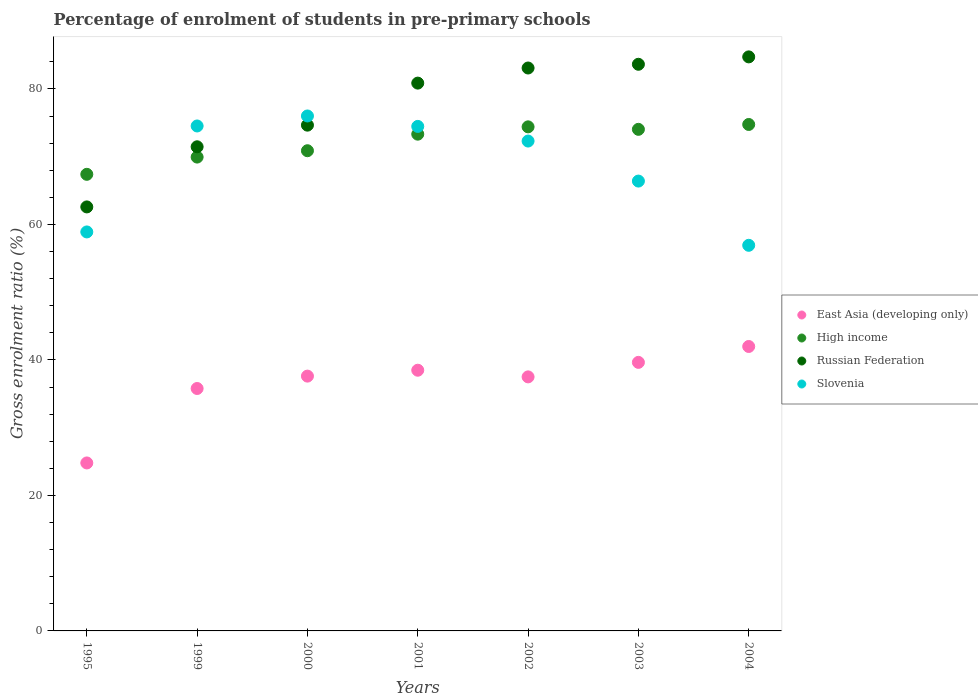Is the number of dotlines equal to the number of legend labels?
Ensure brevity in your answer.  Yes. What is the percentage of students enrolled in pre-primary schools in Russian Federation in 2002?
Your answer should be compact. 83.09. Across all years, what is the maximum percentage of students enrolled in pre-primary schools in Slovenia?
Keep it short and to the point. 76.01. Across all years, what is the minimum percentage of students enrolled in pre-primary schools in East Asia (developing only)?
Make the answer very short. 24.79. What is the total percentage of students enrolled in pre-primary schools in Slovenia in the graph?
Your answer should be very brief. 479.54. What is the difference between the percentage of students enrolled in pre-primary schools in Slovenia in 2000 and that in 2003?
Your answer should be compact. 9.61. What is the difference between the percentage of students enrolled in pre-primary schools in Slovenia in 2003 and the percentage of students enrolled in pre-primary schools in East Asia (developing only) in 1999?
Provide a short and direct response. 30.62. What is the average percentage of students enrolled in pre-primary schools in High income per year?
Make the answer very short. 72.11. In the year 2001, what is the difference between the percentage of students enrolled in pre-primary schools in Russian Federation and percentage of students enrolled in pre-primary schools in East Asia (developing only)?
Your answer should be compact. 42.38. What is the ratio of the percentage of students enrolled in pre-primary schools in East Asia (developing only) in 2000 to that in 2003?
Ensure brevity in your answer.  0.95. What is the difference between the highest and the second highest percentage of students enrolled in pre-primary schools in East Asia (developing only)?
Your answer should be very brief. 2.35. What is the difference between the highest and the lowest percentage of students enrolled in pre-primary schools in East Asia (developing only)?
Keep it short and to the point. 17.19. Is the sum of the percentage of students enrolled in pre-primary schools in East Asia (developing only) in 1999 and 2001 greater than the maximum percentage of students enrolled in pre-primary schools in Slovenia across all years?
Your answer should be very brief. No. Is it the case that in every year, the sum of the percentage of students enrolled in pre-primary schools in High income and percentage of students enrolled in pre-primary schools in East Asia (developing only)  is greater than the percentage of students enrolled in pre-primary schools in Russian Federation?
Your response must be concise. Yes. Is the percentage of students enrolled in pre-primary schools in East Asia (developing only) strictly greater than the percentage of students enrolled in pre-primary schools in Slovenia over the years?
Keep it short and to the point. No. Is the percentage of students enrolled in pre-primary schools in Slovenia strictly less than the percentage of students enrolled in pre-primary schools in Russian Federation over the years?
Offer a very short reply. No. How many years are there in the graph?
Your answer should be compact. 7. What is the difference between two consecutive major ticks on the Y-axis?
Make the answer very short. 20. Are the values on the major ticks of Y-axis written in scientific E-notation?
Give a very brief answer. No. Where does the legend appear in the graph?
Your answer should be very brief. Center right. How many legend labels are there?
Offer a terse response. 4. What is the title of the graph?
Your response must be concise. Percentage of enrolment of students in pre-primary schools. What is the label or title of the X-axis?
Provide a succinct answer. Years. What is the label or title of the Y-axis?
Provide a succinct answer. Gross enrolment ratio (%). What is the Gross enrolment ratio (%) of East Asia (developing only) in 1995?
Give a very brief answer. 24.79. What is the Gross enrolment ratio (%) of High income in 1995?
Your answer should be very brief. 67.4. What is the Gross enrolment ratio (%) in Russian Federation in 1995?
Offer a very short reply. 62.59. What is the Gross enrolment ratio (%) of Slovenia in 1995?
Provide a succinct answer. 58.89. What is the Gross enrolment ratio (%) in East Asia (developing only) in 1999?
Make the answer very short. 35.78. What is the Gross enrolment ratio (%) in High income in 1999?
Provide a short and direct response. 69.94. What is the Gross enrolment ratio (%) of Russian Federation in 1999?
Keep it short and to the point. 71.46. What is the Gross enrolment ratio (%) of Slovenia in 1999?
Keep it short and to the point. 74.54. What is the Gross enrolment ratio (%) of East Asia (developing only) in 2000?
Your answer should be compact. 37.61. What is the Gross enrolment ratio (%) of High income in 2000?
Give a very brief answer. 70.88. What is the Gross enrolment ratio (%) of Russian Federation in 2000?
Your answer should be very brief. 74.66. What is the Gross enrolment ratio (%) in Slovenia in 2000?
Your answer should be very brief. 76.01. What is the Gross enrolment ratio (%) of East Asia (developing only) in 2001?
Offer a terse response. 38.48. What is the Gross enrolment ratio (%) of High income in 2001?
Ensure brevity in your answer.  73.33. What is the Gross enrolment ratio (%) in Russian Federation in 2001?
Make the answer very short. 80.86. What is the Gross enrolment ratio (%) of Slovenia in 2001?
Provide a succinct answer. 74.47. What is the Gross enrolment ratio (%) in East Asia (developing only) in 2002?
Ensure brevity in your answer.  37.5. What is the Gross enrolment ratio (%) in High income in 2002?
Offer a terse response. 74.41. What is the Gross enrolment ratio (%) of Russian Federation in 2002?
Your response must be concise. 83.09. What is the Gross enrolment ratio (%) in Slovenia in 2002?
Keep it short and to the point. 72.31. What is the Gross enrolment ratio (%) in East Asia (developing only) in 2003?
Give a very brief answer. 39.64. What is the Gross enrolment ratio (%) in High income in 2003?
Your answer should be compact. 74.04. What is the Gross enrolment ratio (%) in Russian Federation in 2003?
Your answer should be compact. 83.64. What is the Gross enrolment ratio (%) of Slovenia in 2003?
Your response must be concise. 66.4. What is the Gross enrolment ratio (%) of East Asia (developing only) in 2004?
Give a very brief answer. 41.99. What is the Gross enrolment ratio (%) of High income in 2004?
Offer a terse response. 74.76. What is the Gross enrolment ratio (%) of Russian Federation in 2004?
Provide a succinct answer. 84.73. What is the Gross enrolment ratio (%) in Slovenia in 2004?
Your answer should be very brief. 56.92. Across all years, what is the maximum Gross enrolment ratio (%) of East Asia (developing only)?
Ensure brevity in your answer.  41.99. Across all years, what is the maximum Gross enrolment ratio (%) in High income?
Make the answer very short. 74.76. Across all years, what is the maximum Gross enrolment ratio (%) of Russian Federation?
Keep it short and to the point. 84.73. Across all years, what is the maximum Gross enrolment ratio (%) in Slovenia?
Offer a very short reply. 76.01. Across all years, what is the minimum Gross enrolment ratio (%) in East Asia (developing only)?
Your answer should be very brief. 24.79. Across all years, what is the minimum Gross enrolment ratio (%) of High income?
Your answer should be compact. 67.4. Across all years, what is the minimum Gross enrolment ratio (%) in Russian Federation?
Your answer should be compact. 62.59. Across all years, what is the minimum Gross enrolment ratio (%) of Slovenia?
Provide a short and direct response. 56.92. What is the total Gross enrolment ratio (%) of East Asia (developing only) in the graph?
Make the answer very short. 255.8. What is the total Gross enrolment ratio (%) in High income in the graph?
Ensure brevity in your answer.  504.76. What is the total Gross enrolment ratio (%) in Russian Federation in the graph?
Give a very brief answer. 541.04. What is the total Gross enrolment ratio (%) in Slovenia in the graph?
Make the answer very short. 479.54. What is the difference between the Gross enrolment ratio (%) of East Asia (developing only) in 1995 and that in 1999?
Your response must be concise. -10.99. What is the difference between the Gross enrolment ratio (%) in High income in 1995 and that in 1999?
Provide a succinct answer. -2.54. What is the difference between the Gross enrolment ratio (%) of Russian Federation in 1995 and that in 1999?
Make the answer very short. -8.88. What is the difference between the Gross enrolment ratio (%) of Slovenia in 1995 and that in 1999?
Your answer should be very brief. -15.64. What is the difference between the Gross enrolment ratio (%) in East Asia (developing only) in 1995 and that in 2000?
Provide a succinct answer. -12.82. What is the difference between the Gross enrolment ratio (%) in High income in 1995 and that in 2000?
Your answer should be very brief. -3.48. What is the difference between the Gross enrolment ratio (%) of Russian Federation in 1995 and that in 2000?
Make the answer very short. -12.07. What is the difference between the Gross enrolment ratio (%) of Slovenia in 1995 and that in 2000?
Offer a terse response. -17.12. What is the difference between the Gross enrolment ratio (%) in East Asia (developing only) in 1995 and that in 2001?
Provide a short and direct response. -13.69. What is the difference between the Gross enrolment ratio (%) of High income in 1995 and that in 2001?
Provide a succinct answer. -5.93. What is the difference between the Gross enrolment ratio (%) of Russian Federation in 1995 and that in 2001?
Provide a short and direct response. -18.28. What is the difference between the Gross enrolment ratio (%) in Slovenia in 1995 and that in 2001?
Your answer should be compact. -15.58. What is the difference between the Gross enrolment ratio (%) in East Asia (developing only) in 1995 and that in 2002?
Offer a very short reply. -12.71. What is the difference between the Gross enrolment ratio (%) of High income in 1995 and that in 2002?
Provide a succinct answer. -7.01. What is the difference between the Gross enrolment ratio (%) of Russian Federation in 1995 and that in 2002?
Offer a terse response. -20.51. What is the difference between the Gross enrolment ratio (%) of Slovenia in 1995 and that in 2002?
Provide a short and direct response. -13.42. What is the difference between the Gross enrolment ratio (%) in East Asia (developing only) in 1995 and that in 2003?
Provide a short and direct response. -14.85. What is the difference between the Gross enrolment ratio (%) in High income in 1995 and that in 2003?
Provide a short and direct response. -6.64. What is the difference between the Gross enrolment ratio (%) of Russian Federation in 1995 and that in 2003?
Your answer should be compact. -21.05. What is the difference between the Gross enrolment ratio (%) in Slovenia in 1995 and that in 2003?
Your response must be concise. -7.51. What is the difference between the Gross enrolment ratio (%) of East Asia (developing only) in 1995 and that in 2004?
Provide a succinct answer. -17.19. What is the difference between the Gross enrolment ratio (%) of High income in 1995 and that in 2004?
Provide a succinct answer. -7.36. What is the difference between the Gross enrolment ratio (%) of Russian Federation in 1995 and that in 2004?
Keep it short and to the point. -22.15. What is the difference between the Gross enrolment ratio (%) of Slovenia in 1995 and that in 2004?
Keep it short and to the point. 1.97. What is the difference between the Gross enrolment ratio (%) in East Asia (developing only) in 1999 and that in 2000?
Make the answer very short. -1.83. What is the difference between the Gross enrolment ratio (%) in High income in 1999 and that in 2000?
Provide a short and direct response. -0.94. What is the difference between the Gross enrolment ratio (%) in Russian Federation in 1999 and that in 2000?
Your response must be concise. -3.19. What is the difference between the Gross enrolment ratio (%) of Slovenia in 1999 and that in 2000?
Make the answer very short. -1.48. What is the difference between the Gross enrolment ratio (%) of East Asia (developing only) in 1999 and that in 2001?
Offer a very short reply. -2.7. What is the difference between the Gross enrolment ratio (%) in High income in 1999 and that in 2001?
Offer a terse response. -3.38. What is the difference between the Gross enrolment ratio (%) of Russian Federation in 1999 and that in 2001?
Your answer should be compact. -9.4. What is the difference between the Gross enrolment ratio (%) of Slovenia in 1999 and that in 2001?
Make the answer very short. 0.06. What is the difference between the Gross enrolment ratio (%) in East Asia (developing only) in 1999 and that in 2002?
Your answer should be compact. -1.72. What is the difference between the Gross enrolment ratio (%) in High income in 1999 and that in 2002?
Provide a succinct answer. -4.46. What is the difference between the Gross enrolment ratio (%) of Russian Federation in 1999 and that in 2002?
Offer a very short reply. -11.63. What is the difference between the Gross enrolment ratio (%) of Slovenia in 1999 and that in 2002?
Your answer should be compact. 2.23. What is the difference between the Gross enrolment ratio (%) of East Asia (developing only) in 1999 and that in 2003?
Ensure brevity in your answer.  -3.86. What is the difference between the Gross enrolment ratio (%) of High income in 1999 and that in 2003?
Make the answer very short. -4.09. What is the difference between the Gross enrolment ratio (%) in Russian Federation in 1999 and that in 2003?
Make the answer very short. -12.18. What is the difference between the Gross enrolment ratio (%) in Slovenia in 1999 and that in 2003?
Make the answer very short. 8.13. What is the difference between the Gross enrolment ratio (%) of East Asia (developing only) in 1999 and that in 2004?
Your response must be concise. -6.2. What is the difference between the Gross enrolment ratio (%) of High income in 1999 and that in 2004?
Your answer should be very brief. -4.81. What is the difference between the Gross enrolment ratio (%) of Russian Federation in 1999 and that in 2004?
Ensure brevity in your answer.  -13.27. What is the difference between the Gross enrolment ratio (%) in Slovenia in 1999 and that in 2004?
Your response must be concise. 17.62. What is the difference between the Gross enrolment ratio (%) of East Asia (developing only) in 2000 and that in 2001?
Your answer should be compact. -0.87. What is the difference between the Gross enrolment ratio (%) in High income in 2000 and that in 2001?
Keep it short and to the point. -2.44. What is the difference between the Gross enrolment ratio (%) in Russian Federation in 2000 and that in 2001?
Your answer should be very brief. -6.21. What is the difference between the Gross enrolment ratio (%) of Slovenia in 2000 and that in 2001?
Offer a terse response. 1.54. What is the difference between the Gross enrolment ratio (%) in East Asia (developing only) in 2000 and that in 2002?
Give a very brief answer. 0.11. What is the difference between the Gross enrolment ratio (%) in High income in 2000 and that in 2002?
Your answer should be compact. -3.52. What is the difference between the Gross enrolment ratio (%) of Russian Federation in 2000 and that in 2002?
Provide a short and direct response. -8.44. What is the difference between the Gross enrolment ratio (%) of Slovenia in 2000 and that in 2002?
Give a very brief answer. 3.7. What is the difference between the Gross enrolment ratio (%) of East Asia (developing only) in 2000 and that in 2003?
Give a very brief answer. -2.03. What is the difference between the Gross enrolment ratio (%) in High income in 2000 and that in 2003?
Ensure brevity in your answer.  -3.16. What is the difference between the Gross enrolment ratio (%) in Russian Federation in 2000 and that in 2003?
Your answer should be very brief. -8.99. What is the difference between the Gross enrolment ratio (%) in Slovenia in 2000 and that in 2003?
Ensure brevity in your answer.  9.61. What is the difference between the Gross enrolment ratio (%) of East Asia (developing only) in 2000 and that in 2004?
Your answer should be very brief. -4.37. What is the difference between the Gross enrolment ratio (%) in High income in 2000 and that in 2004?
Your answer should be very brief. -3.87. What is the difference between the Gross enrolment ratio (%) of Russian Federation in 2000 and that in 2004?
Provide a short and direct response. -10.08. What is the difference between the Gross enrolment ratio (%) of Slovenia in 2000 and that in 2004?
Offer a terse response. 19.09. What is the difference between the Gross enrolment ratio (%) in East Asia (developing only) in 2001 and that in 2002?
Your answer should be compact. 0.98. What is the difference between the Gross enrolment ratio (%) of High income in 2001 and that in 2002?
Your response must be concise. -1.08. What is the difference between the Gross enrolment ratio (%) of Russian Federation in 2001 and that in 2002?
Make the answer very short. -2.23. What is the difference between the Gross enrolment ratio (%) of Slovenia in 2001 and that in 2002?
Your answer should be compact. 2.16. What is the difference between the Gross enrolment ratio (%) in East Asia (developing only) in 2001 and that in 2003?
Offer a terse response. -1.16. What is the difference between the Gross enrolment ratio (%) of High income in 2001 and that in 2003?
Keep it short and to the point. -0.71. What is the difference between the Gross enrolment ratio (%) in Russian Federation in 2001 and that in 2003?
Provide a succinct answer. -2.78. What is the difference between the Gross enrolment ratio (%) in Slovenia in 2001 and that in 2003?
Provide a short and direct response. 8.07. What is the difference between the Gross enrolment ratio (%) of East Asia (developing only) in 2001 and that in 2004?
Your answer should be very brief. -3.5. What is the difference between the Gross enrolment ratio (%) in High income in 2001 and that in 2004?
Provide a succinct answer. -1.43. What is the difference between the Gross enrolment ratio (%) in Russian Federation in 2001 and that in 2004?
Keep it short and to the point. -3.87. What is the difference between the Gross enrolment ratio (%) of Slovenia in 2001 and that in 2004?
Your answer should be very brief. 17.55. What is the difference between the Gross enrolment ratio (%) of East Asia (developing only) in 2002 and that in 2003?
Keep it short and to the point. -2.14. What is the difference between the Gross enrolment ratio (%) in High income in 2002 and that in 2003?
Your answer should be compact. 0.37. What is the difference between the Gross enrolment ratio (%) of Russian Federation in 2002 and that in 2003?
Make the answer very short. -0.55. What is the difference between the Gross enrolment ratio (%) of Slovenia in 2002 and that in 2003?
Give a very brief answer. 5.91. What is the difference between the Gross enrolment ratio (%) in East Asia (developing only) in 2002 and that in 2004?
Keep it short and to the point. -4.49. What is the difference between the Gross enrolment ratio (%) of High income in 2002 and that in 2004?
Keep it short and to the point. -0.35. What is the difference between the Gross enrolment ratio (%) in Russian Federation in 2002 and that in 2004?
Ensure brevity in your answer.  -1.64. What is the difference between the Gross enrolment ratio (%) of Slovenia in 2002 and that in 2004?
Your answer should be very brief. 15.39. What is the difference between the Gross enrolment ratio (%) in East Asia (developing only) in 2003 and that in 2004?
Provide a short and direct response. -2.35. What is the difference between the Gross enrolment ratio (%) of High income in 2003 and that in 2004?
Give a very brief answer. -0.72. What is the difference between the Gross enrolment ratio (%) of Russian Federation in 2003 and that in 2004?
Make the answer very short. -1.09. What is the difference between the Gross enrolment ratio (%) of Slovenia in 2003 and that in 2004?
Offer a terse response. 9.48. What is the difference between the Gross enrolment ratio (%) of East Asia (developing only) in 1995 and the Gross enrolment ratio (%) of High income in 1999?
Offer a terse response. -45.15. What is the difference between the Gross enrolment ratio (%) in East Asia (developing only) in 1995 and the Gross enrolment ratio (%) in Russian Federation in 1999?
Provide a succinct answer. -46.67. What is the difference between the Gross enrolment ratio (%) of East Asia (developing only) in 1995 and the Gross enrolment ratio (%) of Slovenia in 1999?
Ensure brevity in your answer.  -49.74. What is the difference between the Gross enrolment ratio (%) of High income in 1995 and the Gross enrolment ratio (%) of Russian Federation in 1999?
Your answer should be compact. -4.06. What is the difference between the Gross enrolment ratio (%) of High income in 1995 and the Gross enrolment ratio (%) of Slovenia in 1999?
Offer a very short reply. -7.14. What is the difference between the Gross enrolment ratio (%) of Russian Federation in 1995 and the Gross enrolment ratio (%) of Slovenia in 1999?
Offer a very short reply. -11.95. What is the difference between the Gross enrolment ratio (%) in East Asia (developing only) in 1995 and the Gross enrolment ratio (%) in High income in 2000?
Your answer should be very brief. -46.09. What is the difference between the Gross enrolment ratio (%) of East Asia (developing only) in 1995 and the Gross enrolment ratio (%) of Russian Federation in 2000?
Keep it short and to the point. -49.86. What is the difference between the Gross enrolment ratio (%) in East Asia (developing only) in 1995 and the Gross enrolment ratio (%) in Slovenia in 2000?
Make the answer very short. -51.22. What is the difference between the Gross enrolment ratio (%) in High income in 1995 and the Gross enrolment ratio (%) in Russian Federation in 2000?
Offer a terse response. -7.26. What is the difference between the Gross enrolment ratio (%) of High income in 1995 and the Gross enrolment ratio (%) of Slovenia in 2000?
Give a very brief answer. -8.61. What is the difference between the Gross enrolment ratio (%) of Russian Federation in 1995 and the Gross enrolment ratio (%) of Slovenia in 2000?
Offer a very short reply. -13.42. What is the difference between the Gross enrolment ratio (%) in East Asia (developing only) in 1995 and the Gross enrolment ratio (%) in High income in 2001?
Offer a terse response. -48.53. What is the difference between the Gross enrolment ratio (%) of East Asia (developing only) in 1995 and the Gross enrolment ratio (%) of Russian Federation in 2001?
Provide a succinct answer. -56.07. What is the difference between the Gross enrolment ratio (%) of East Asia (developing only) in 1995 and the Gross enrolment ratio (%) of Slovenia in 2001?
Your answer should be compact. -49.68. What is the difference between the Gross enrolment ratio (%) in High income in 1995 and the Gross enrolment ratio (%) in Russian Federation in 2001?
Your response must be concise. -13.46. What is the difference between the Gross enrolment ratio (%) of High income in 1995 and the Gross enrolment ratio (%) of Slovenia in 2001?
Provide a short and direct response. -7.07. What is the difference between the Gross enrolment ratio (%) in Russian Federation in 1995 and the Gross enrolment ratio (%) in Slovenia in 2001?
Your answer should be compact. -11.88. What is the difference between the Gross enrolment ratio (%) of East Asia (developing only) in 1995 and the Gross enrolment ratio (%) of High income in 2002?
Give a very brief answer. -49.61. What is the difference between the Gross enrolment ratio (%) in East Asia (developing only) in 1995 and the Gross enrolment ratio (%) in Russian Federation in 2002?
Your answer should be very brief. -58.3. What is the difference between the Gross enrolment ratio (%) in East Asia (developing only) in 1995 and the Gross enrolment ratio (%) in Slovenia in 2002?
Keep it short and to the point. -47.52. What is the difference between the Gross enrolment ratio (%) in High income in 1995 and the Gross enrolment ratio (%) in Russian Federation in 2002?
Ensure brevity in your answer.  -15.69. What is the difference between the Gross enrolment ratio (%) of High income in 1995 and the Gross enrolment ratio (%) of Slovenia in 2002?
Offer a very short reply. -4.91. What is the difference between the Gross enrolment ratio (%) of Russian Federation in 1995 and the Gross enrolment ratio (%) of Slovenia in 2002?
Ensure brevity in your answer.  -9.72. What is the difference between the Gross enrolment ratio (%) of East Asia (developing only) in 1995 and the Gross enrolment ratio (%) of High income in 2003?
Keep it short and to the point. -49.24. What is the difference between the Gross enrolment ratio (%) in East Asia (developing only) in 1995 and the Gross enrolment ratio (%) in Russian Federation in 2003?
Keep it short and to the point. -58.85. What is the difference between the Gross enrolment ratio (%) of East Asia (developing only) in 1995 and the Gross enrolment ratio (%) of Slovenia in 2003?
Your response must be concise. -41.61. What is the difference between the Gross enrolment ratio (%) of High income in 1995 and the Gross enrolment ratio (%) of Russian Federation in 2003?
Keep it short and to the point. -16.24. What is the difference between the Gross enrolment ratio (%) in High income in 1995 and the Gross enrolment ratio (%) in Slovenia in 2003?
Offer a very short reply. 1. What is the difference between the Gross enrolment ratio (%) of Russian Federation in 1995 and the Gross enrolment ratio (%) of Slovenia in 2003?
Your response must be concise. -3.81. What is the difference between the Gross enrolment ratio (%) in East Asia (developing only) in 1995 and the Gross enrolment ratio (%) in High income in 2004?
Offer a very short reply. -49.96. What is the difference between the Gross enrolment ratio (%) of East Asia (developing only) in 1995 and the Gross enrolment ratio (%) of Russian Federation in 2004?
Your answer should be very brief. -59.94. What is the difference between the Gross enrolment ratio (%) in East Asia (developing only) in 1995 and the Gross enrolment ratio (%) in Slovenia in 2004?
Provide a succinct answer. -32.13. What is the difference between the Gross enrolment ratio (%) of High income in 1995 and the Gross enrolment ratio (%) of Russian Federation in 2004?
Your response must be concise. -17.34. What is the difference between the Gross enrolment ratio (%) of High income in 1995 and the Gross enrolment ratio (%) of Slovenia in 2004?
Provide a short and direct response. 10.48. What is the difference between the Gross enrolment ratio (%) in Russian Federation in 1995 and the Gross enrolment ratio (%) in Slovenia in 2004?
Your response must be concise. 5.67. What is the difference between the Gross enrolment ratio (%) of East Asia (developing only) in 1999 and the Gross enrolment ratio (%) of High income in 2000?
Keep it short and to the point. -35.1. What is the difference between the Gross enrolment ratio (%) in East Asia (developing only) in 1999 and the Gross enrolment ratio (%) in Russian Federation in 2000?
Offer a very short reply. -38.87. What is the difference between the Gross enrolment ratio (%) in East Asia (developing only) in 1999 and the Gross enrolment ratio (%) in Slovenia in 2000?
Your answer should be very brief. -40.23. What is the difference between the Gross enrolment ratio (%) in High income in 1999 and the Gross enrolment ratio (%) in Russian Federation in 2000?
Make the answer very short. -4.71. What is the difference between the Gross enrolment ratio (%) in High income in 1999 and the Gross enrolment ratio (%) in Slovenia in 2000?
Ensure brevity in your answer.  -6.07. What is the difference between the Gross enrolment ratio (%) of Russian Federation in 1999 and the Gross enrolment ratio (%) of Slovenia in 2000?
Offer a very short reply. -4.55. What is the difference between the Gross enrolment ratio (%) of East Asia (developing only) in 1999 and the Gross enrolment ratio (%) of High income in 2001?
Keep it short and to the point. -37.54. What is the difference between the Gross enrolment ratio (%) in East Asia (developing only) in 1999 and the Gross enrolment ratio (%) in Russian Federation in 2001?
Offer a very short reply. -45.08. What is the difference between the Gross enrolment ratio (%) of East Asia (developing only) in 1999 and the Gross enrolment ratio (%) of Slovenia in 2001?
Your answer should be very brief. -38.69. What is the difference between the Gross enrolment ratio (%) in High income in 1999 and the Gross enrolment ratio (%) in Russian Federation in 2001?
Ensure brevity in your answer.  -10.92. What is the difference between the Gross enrolment ratio (%) of High income in 1999 and the Gross enrolment ratio (%) of Slovenia in 2001?
Your answer should be very brief. -4.53. What is the difference between the Gross enrolment ratio (%) of Russian Federation in 1999 and the Gross enrolment ratio (%) of Slovenia in 2001?
Give a very brief answer. -3.01. What is the difference between the Gross enrolment ratio (%) in East Asia (developing only) in 1999 and the Gross enrolment ratio (%) in High income in 2002?
Keep it short and to the point. -38.62. What is the difference between the Gross enrolment ratio (%) of East Asia (developing only) in 1999 and the Gross enrolment ratio (%) of Russian Federation in 2002?
Keep it short and to the point. -47.31. What is the difference between the Gross enrolment ratio (%) of East Asia (developing only) in 1999 and the Gross enrolment ratio (%) of Slovenia in 2002?
Your response must be concise. -36.53. What is the difference between the Gross enrolment ratio (%) in High income in 1999 and the Gross enrolment ratio (%) in Russian Federation in 2002?
Give a very brief answer. -13.15. What is the difference between the Gross enrolment ratio (%) of High income in 1999 and the Gross enrolment ratio (%) of Slovenia in 2002?
Keep it short and to the point. -2.37. What is the difference between the Gross enrolment ratio (%) of Russian Federation in 1999 and the Gross enrolment ratio (%) of Slovenia in 2002?
Your answer should be compact. -0.85. What is the difference between the Gross enrolment ratio (%) of East Asia (developing only) in 1999 and the Gross enrolment ratio (%) of High income in 2003?
Keep it short and to the point. -38.25. What is the difference between the Gross enrolment ratio (%) in East Asia (developing only) in 1999 and the Gross enrolment ratio (%) in Russian Federation in 2003?
Your response must be concise. -47.86. What is the difference between the Gross enrolment ratio (%) in East Asia (developing only) in 1999 and the Gross enrolment ratio (%) in Slovenia in 2003?
Provide a succinct answer. -30.62. What is the difference between the Gross enrolment ratio (%) in High income in 1999 and the Gross enrolment ratio (%) in Russian Federation in 2003?
Provide a succinct answer. -13.7. What is the difference between the Gross enrolment ratio (%) of High income in 1999 and the Gross enrolment ratio (%) of Slovenia in 2003?
Keep it short and to the point. 3.54. What is the difference between the Gross enrolment ratio (%) of Russian Federation in 1999 and the Gross enrolment ratio (%) of Slovenia in 2003?
Your answer should be very brief. 5.06. What is the difference between the Gross enrolment ratio (%) of East Asia (developing only) in 1999 and the Gross enrolment ratio (%) of High income in 2004?
Provide a succinct answer. -38.97. What is the difference between the Gross enrolment ratio (%) of East Asia (developing only) in 1999 and the Gross enrolment ratio (%) of Russian Federation in 2004?
Provide a short and direct response. -48.95. What is the difference between the Gross enrolment ratio (%) of East Asia (developing only) in 1999 and the Gross enrolment ratio (%) of Slovenia in 2004?
Make the answer very short. -21.14. What is the difference between the Gross enrolment ratio (%) of High income in 1999 and the Gross enrolment ratio (%) of Russian Federation in 2004?
Give a very brief answer. -14.79. What is the difference between the Gross enrolment ratio (%) in High income in 1999 and the Gross enrolment ratio (%) in Slovenia in 2004?
Give a very brief answer. 13.02. What is the difference between the Gross enrolment ratio (%) in Russian Federation in 1999 and the Gross enrolment ratio (%) in Slovenia in 2004?
Make the answer very short. 14.54. What is the difference between the Gross enrolment ratio (%) of East Asia (developing only) in 2000 and the Gross enrolment ratio (%) of High income in 2001?
Provide a short and direct response. -35.72. What is the difference between the Gross enrolment ratio (%) of East Asia (developing only) in 2000 and the Gross enrolment ratio (%) of Russian Federation in 2001?
Provide a short and direct response. -43.25. What is the difference between the Gross enrolment ratio (%) of East Asia (developing only) in 2000 and the Gross enrolment ratio (%) of Slovenia in 2001?
Your response must be concise. -36.86. What is the difference between the Gross enrolment ratio (%) of High income in 2000 and the Gross enrolment ratio (%) of Russian Federation in 2001?
Offer a very short reply. -9.98. What is the difference between the Gross enrolment ratio (%) of High income in 2000 and the Gross enrolment ratio (%) of Slovenia in 2001?
Your answer should be very brief. -3.59. What is the difference between the Gross enrolment ratio (%) in Russian Federation in 2000 and the Gross enrolment ratio (%) in Slovenia in 2001?
Provide a short and direct response. 0.19. What is the difference between the Gross enrolment ratio (%) in East Asia (developing only) in 2000 and the Gross enrolment ratio (%) in High income in 2002?
Offer a very short reply. -36.79. What is the difference between the Gross enrolment ratio (%) in East Asia (developing only) in 2000 and the Gross enrolment ratio (%) in Russian Federation in 2002?
Offer a very short reply. -45.48. What is the difference between the Gross enrolment ratio (%) of East Asia (developing only) in 2000 and the Gross enrolment ratio (%) of Slovenia in 2002?
Your response must be concise. -34.7. What is the difference between the Gross enrolment ratio (%) of High income in 2000 and the Gross enrolment ratio (%) of Russian Federation in 2002?
Make the answer very short. -12.21. What is the difference between the Gross enrolment ratio (%) of High income in 2000 and the Gross enrolment ratio (%) of Slovenia in 2002?
Your answer should be very brief. -1.43. What is the difference between the Gross enrolment ratio (%) of Russian Federation in 2000 and the Gross enrolment ratio (%) of Slovenia in 2002?
Your answer should be compact. 2.35. What is the difference between the Gross enrolment ratio (%) in East Asia (developing only) in 2000 and the Gross enrolment ratio (%) in High income in 2003?
Keep it short and to the point. -36.43. What is the difference between the Gross enrolment ratio (%) of East Asia (developing only) in 2000 and the Gross enrolment ratio (%) of Russian Federation in 2003?
Give a very brief answer. -46.03. What is the difference between the Gross enrolment ratio (%) in East Asia (developing only) in 2000 and the Gross enrolment ratio (%) in Slovenia in 2003?
Your response must be concise. -28.79. What is the difference between the Gross enrolment ratio (%) in High income in 2000 and the Gross enrolment ratio (%) in Russian Federation in 2003?
Offer a very short reply. -12.76. What is the difference between the Gross enrolment ratio (%) of High income in 2000 and the Gross enrolment ratio (%) of Slovenia in 2003?
Ensure brevity in your answer.  4.48. What is the difference between the Gross enrolment ratio (%) in Russian Federation in 2000 and the Gross enrolment ratio (%) in Slovenia in 2003?
Offer a terse response. 8.26. What is the difference between the Gross enrolment ratio (%) in East Asia (developing only) in 2000 and the Gross enrolment ratio (%) in High income in 2004?
Give a very brief answer. -37.15. What is the difference between the Gross enrolment ratio (%) of East Asia (developing only) in 2000 and the Gross enrolment ratio (%) of Russian Federation in 2004?
Your answer should be very brief. -47.12. What is the difference between the Gross enrolment ratio (%) in East Asia (developing only) in 2000 and the Gross enrolment ratio (%) in Slovenia in 2004?
Ensure brevity in your answer.  -19.31. What is the difference between the Gross enrolment ratio (%) of High income in 2000 and the Gross enrolment ratio (%) of Russian Federation in 2004?
Ensure brevity in your answer.  -13.85. What is the difference between the Gross enrolment ratio (%) in High income in 2000 and the Gross enrolment ratio (%) in Slovenia in 2004?
Your answer should be very brief. 13.96. What is the difference between the Gross enrolment ratio (%) of Russian Federation in 2000 and the Gross enrolment ratio (%) of Slovenia in 2004?
Your answer should be compact. 17.74. What is the difference between the Gross enrolment ratio (%) of East Asia (developing only) in 2001 and the Gross enrolment ratio (%) of High income in 2002?
Keep it short and to the point. -35.92. What is the difference between the Gross enrolment ratio (%) in East Asia (developing only) in 2001 and the Gross enrolment ratio (%) in Russian Federation in 2002?
Give a very brief answer. -44.61. What is the difference between the Gross enrolment ratio (%) of East Asia (developing only) in 2001 and the Gross enrolment ratio (%) of Slovenia in 2002?
Your response must be concise. -33.83. What is the difference between the Gross enrolment ratio (%) in High income in 2001 and the Gross enrolment ratio (%) in Russian Federation in 2002?
Ensure brevity in your answer.  -9.77. What is the difference between the Gross enrolment ratio (%) in High income in 2001 and the Gross enrolment ratio (%) in Slovenia in 2002?
Make the answer very short. 1.02. What is the difference between the Gross enrolment ratio (%) in Russian Federation in 2001 and the Gross enrolment ratio (%) in Slovenia in 2002?
Offer a terse response. 8.55. What is the difference between the Gross enrolment ratio (%) of East Asia (developing only) in 2001 and the Gross enrolment ratio (%) of High income in 2003?
Offer a terse response. -35.56. What is the difference between the Gross enrolment ratio (%) of East Asia (developing only) in 2001 and the Gross enrolment ratio (%) of Russian Federation in 2003?
Make the answer very short. -45.16. What is the difference between the Gross enrolment ratio (%) in East Asia (developing only) in 2001 and the Gross enrolment ratio (%) in Slovenia in 2003?
Offer a very short reply. -27.92. What is the difference between the Gross enrolment ratio (%) of High income in 2001 and the Gross enrolment ratio (%) of Russian Federation in 2003?
Your response must be concise. -10.32. What is the difference between the Gross enrolment ratio (%) in High income in 2001 and the Gross enrolment ratio (%) in Slovenia in 2003?
Offer a very short reply. 6.93. What is the difference between the Gross enrolment ratio (%) of Russian Federation in 2001 and the Gross enrolment ratio (%) of Slovenia in 2003?
Keep it short and to the point. 14.46. What is the difference between the Gross enrolment ratio (%) in East Asia (developing only) in 2001 and the Gross enrolment ratio (%) in High income in 2004?
Keep it short and to the point. -36.28. What is the difference between the Gross enrolment ratio (%) in East Asia (developing only) in 2001 and the Gross enrolment ratio (%) in Russian Federation in 2004?
Provide a short and direct response. -46.25. What is the difference between the Gross enrolment ratio (%) in East Asia (developing only) in 2001 and the Gross enrolment ratio (%) in Slovenia in 2004?
Your response must be concise. -18.44. What is the difference between the Gross enrolment ratio (%) of High income in 2001 and the Gross enrolment ratio (%) of Russian Federation in 2004?
Make the answer very short. -11.41. What is the difference between the Gross enrolment ratio (%) in High income in 2001 and the Gross enrolment ratio (%) in Slovenia in 2004?
Your answer should be compact. 16.41. What is the difference between the Gross enrolment ratio (%) of Russian Federation in 2001 and the Gross enrolment ratio (%) of Slovenia in 2004?
Make the answer very short. 23.94. What is the difference between the Gross enrolment ratio (%) in East Asia (developing only) in 2002 and the Gross enrolment ratio (%) in High income in 2003?
Provide a short and direct response. -36.54. What is the difference between the Gross enrolment ratio (%) in East Asia (developing only) in 2002 and the Gross enrolment ratio (%) in Russian Federation in 2003?
Provide a succinct answer. -46.14. What is the difference between the Gross enrolment ratio (%) of East Asia (developing only) in 2002 and the Gross enrolment ratio (%) of Slovenia in 2003?
Your answer should be very brief. -28.9. What is the difference between the Gross enrolment ratio (%) of High income in 2002 and the Gross enrolment ratio (%) of Russian Federation in 2003?
Offer a very short reply. -9.24. What is the difference between the Gross enrolment ratio (%) in High income in 2002 and the Gross enrolment ratio (%) in Slovenia in 2003?
Provide a succinct answer. 8. What is the difference between the Gross enrolment ratio (%) of Russian Federation in 2002 and the Gross enrolment ratio (%) of Slovenia in 2003?
Keep it short and to the point. 16.69. What is the difference between the Gross enrolment ratio (%) in East Asia (developing only) in 2002 and the Gross enrolment ratio (%) in High income in 2004?
Provide a short and direct response. -37.26. What is the difference between the Gross enrolment ratio (%) of East Asia (developing only) in 2002 and the Gross enrolment ratio (%) of Russian Federation in 2004?
Make the answer very short. -47.24. What is the difference between the Gross enrolment ratio (%) of East Asia (developing only) in 2002 and the Gross enrolment ratio (%) of Slovenia in 2004?
Your response must be concise. -19.42. What is the difference between the Gross enrolment ratio (%) of High income in 2002 and the Gross enrolment ratio (%) of Russian Federation in 2004?
Your answer should be compact. -10.33. What is the difference between the Gross enrolment ratio (%) in High income in 2002 and the Gross enrolment ratio (%) in Slovenia in 2004?
Offer a terse response. 17.49. What is the difference between the Gross enrolment ratio (%) in Russian Federation in 2002 and the Gross enrolment ratio (%) in Slovenia in 2004?
Provide a succinct answer. 26.17. What is the difference between the Gross enrolment ratio (%) of East Asia (developing only) in 2003 and the Gross enrolment ratio (%) of High income in 2004?
Your answer should be compact. -35.12. What is the difference between the Gross enrolment ratio (%) in East Asia (developing only) in 2003 and the Gross enrolment ratio (%) in Russian Federation in 2004?
Your response must be concise. -45.09. What is the difference between the Gross enrolment ratio (%) of East Asia (developing only) in 2003 and the Gross enrolment ratio (%) of Slovenia in 2004?
Keep it short and to the point. -17.28. What is the difference between the Gross enrolment ratio (%) in High income in 2003 and the Gross enrolment ratio (%) in Russian Federation in 2004?
Your response must be concise. -10.7. What is the difference between the Gross enrolment ratio (%) of High income in 2003 and the Gross enrolment ratio (%) of Slovenia in 2004?
Offer a very short reply. 17.12. What is the difference between the Gross enrolment ratio (%) in Russian Federation in 2003 and the Gross enrolment ratio (%) in Slovenia in 2004?
Your answer should be compact. 26.72. What is the average Gross enrolment ratio (%) of East Asia (developing only) per year?
Offer a very short reply. 36.54. What is the average Gross enrolment ratio (%) of High income per year?
Make the answer very short. 72.11. What is the average Gross enrolment ratio (%) of Russian Federation per year?
Your answer should be compact. 77.29. What is the average Gross enrolment ratio (%) in Slovenia per year?
Make the answer very short. 68.51. In the year 1995, what is the difference between the Gross enrolment ratio (%) in East Asia (developing only) and Gross enrolment ratio (%) in High income?
Offer a terse response. -42.6. In the year 1995, what is the difference between the Gross enrolment ratio (%) of East Asia (developing only) and Gross enrolment ratio (%) of Russian Federation?
Make the answer very short. -37.79. In the year 1995, what is the difference between the Gross enrolment ratio (%) in East Asia (developing only) and Gross enrolment ratio (%) in Slovenia?
Provide a short and direct response. -34.1. In the year 1995, what is the difference between the Gross enrolment ratio (%) in High income and Gross enrolment ratio (%) in Russian Federation?
Your answer should be very brief. 4.81. In the year 1995, what is the difference between the Gross enrolment ratio (%) in High income and Gross enrolment ratio (%) in Slovenia?
Your answer should be compact. 8.51. In the year 1995, what is the difference between the Gross enrolment ratio (%) in Russian Federation and Gross enrolment ratio (%) in Slovenia?
Ensure brevity in your answer.  3.69. In the year 1999, what is the difference between the Gross enrolment ratio (%) in East Asia (developing only) and Gross enrolment ratio (%) in High income?
Your response must be concise. -34.16. In the year 1999, what is the difference between the Gross enrolment ratio (%) of East Asia (developing only) and Gross enrolment ratio (%) of Russian Federation?
Make the answer very short. -35.68. In the year 1999, what is the difference between the Gross enrolment ratio (%) in East Asia (developing only) and Gross enrolment ratio (%) in Slovenia?
Provide a short and direct response. -38.75. In the year 1999, what is the difference between the Gross enrolment ratio (%) in High income and Gross enrolment ratio (%) in Russian Federation?
Offer a very short reply. -1.52. In the year 1999, what is the difference between the Gross enrolment ratio (%) in High income and Gross enrolment ratio (%) in Slovenia?
Give a very brief answer. -4.59. In the year 1999, what is the difference between the Gross enrolment ratio (%) of Russian Federation and Gross enrolment ratio (%) of Slovenia?
Provide a short and direct response. -3.07. In the year 2000, what is the difference between the Gross enrolment ratio (%) in East Asia (developing only) and Gross enrolment ratio (%) in High income?
Your answer should be compact. -33.27. In the year 2000, what is the difference between the Gross enrolment ratio (%) of East Asia (developing only) and Gross enrolment ratio (%) of Russian Federation?
Make the answer very short. -37.04. In the year 2000, what is the difference between the Gross enrolment ratio (%) of East Asia (developing only) and Gross enrolment ratio (%) of Slovenia?
Your answer should be very brief. -38.4. In the year 2000, what is the difference between the Gross enrolment ratio (%) of High income and Gross enrolment ratio (%) of Russian Federation?
Offer a very short reply. -3.77. In the year 2000, what is the difference between the Gross enrolment ratio (%) in High income and Gross enrolment ratio (%) in Slovenia?
Give a very brief answer. -5.13. In the year 2000, what is the difference between the Gross enrolment ratio (%) in Russian Federation and Gross enrolment ratio (%) in Slovenia?
Your response must be concise. -1.36. In the year 2001, what is the difference between the Gross enrolment ratio (%) in East Asia (developing only) and Gross enrolment ratio (%) in High income?
Give a very brief answer. -34.85. In the year 2001, what is the difference between the Gross enrolment ratio (%) of East Asia (developing only) and Gross enrolment ratio (%) of Russian Federation?
Offer a very short reply. -42.38. In the year 2001, what is the difference between the Gross enrolment ratio (%) of East Asia (developing only) and Gross enrolment ratio (%) of Slovenia?
Provide a short and direct response. -35.99. In the year 2001, what is the difference between the Gross enrolment ratio (%) in High income and Gross enrolment ratio (%) in Russian Federation?
Your answer should be very brief. -7.54. In the year 2001, what is the difference between the Gross enrolment ratio (%) of High income and Gross enrolment ratio (%) of Slovenia?
Ensure brevity in your answer.  -1.14. In the year 2001, what is the difference between the Gross enrolment ratio (%) in Russian Federation and Gross enrolment ratio (%) in Slovenia?
Give a very brief answer. 6.39. In the year 2002, what is the difference between the Gross enrolment ratio (%) of East Asia (developing only) and Gross enrolment ratio (%) of High income?
Your answer should be very brief. -36.91. In the year 2002, what is the difference between the Gross enrolment ratio (%) of East Asia (developing only) and Gross enrolment ratio (%) of Russian Federation?
Ensure brevity in your answer.  -45.59. In the year 2002, what is the difference between the Gross enrolment ratio (%) of East Asia (developing only) and Gross enrolment ratio (%) of Slovenia?
Provide a short and direct response. -34.81. In the year 2002, what is the difference between the Gross enrolment ratio (%) of High income and Gross enrolment ratio (%) of Russian Federation?
Offer a very short reply. -8.69. In the year 2002, what is the difference between the Gross enrolment ratio (%) in High income and Gross enrolment ratio (%) in Slovenia?
Make the answer very short. 2.1. In the year 2002, what is the difference between the Gross enrolment ratio (%) of Russian Federation and Gross enrolment ratio (%) of Slovenia?
Make the answer very short. 10.78. In the year 2003, what is the difference between the Gross enrolment ratio (%) in East Asia (developing only) and Gross enrolment ratio (%) in High income?
Make the answer very short. -34.4. In the year 2003, what is the difference between the Gross enrolment ratio (%) in East Asia (developing only) and Gross enrolment ratio (%) in Russian Federation?
Provide a succinct answer. -44. In the year 2003, what is the difference between the Gross enrolment ratio (%) in East Asia (developing only) and Gross enrolment ratio (%) in Slovenia?
Ensure brevity in your answer.  -26.76. In the year 2003, what is the difference between the Gross enrolment ratio (%) in High income and Gross enrolment ratio (%) in Russian Federation?
Give a very brief answer. -9.6. In the year 2003, what is the difference between the Gross enrolment ratio (%) in High income and Gross enrolment ratio (%) in Slovenia?
Your response must be concise. 7.64. In the year 2003, what is the difference between the Gross enrolment ratio (%) of Russian Federation and Gross enrolment ratio (%) of Slovenia?
Offer a terse response. 17.24. In the year 2004, what is the difference between the Gross enrolment ratio (%) in East Asia (developing only) and Gross enrolment ratio (%) in High income?
Make the answer very short. -32.77. In the year 2004, what is the difference between the Gross enrolment ratio (%) of East Asia (developing only) and Gross enrolment ratio (%) of Russian Federation?
Your answer should be compact. -42.75. In the year 2004, what is the difference between the Gross enrolment ratio (%) of East Asia (developing only) and Gross enrolment ratio (%) of Slovenia?
Give a very brief answer. -14.93. In the year 2004, what is the difference between the Gross enrolment ratio (%) of High income and Gross enrolment ratio (%) of Russian Federation?
Your answer should be compact. -9.98. In the year 2004, what is the difference between the Gross enrolment ratio (%) of High income and Gross enrolment ratio (%) of Slovenia?
Make the answer very short. 17.84. In the year 2004, what is the difference between the Gross enrolment ratio (%) in Russian Federation and Gross enrolment ratio (%) in Slovenia?
Provide a succinct answer. 27.81. What is the ratio of the Gross enrolment ratio (%) in East Asia (developing only) in 1995 to that in 1999?
Make the answer very short. 0.69. What is the ratio of the Gross enrolment ratio (%) in High income in 1995 to that in 1999?
Ensure brevity in your answer.  0.96. What is the ratio of the Gross enrolment ratio (%) in Russian Federation in 1995 to that in 1999?
Offer a very short reply. 0.88. What is the ratio of the Gross enrolment ratio (%) in Slovenia in 1995 to that in 1999?
Your response must be concise. 0.79. What is the ratio of the Gross enrolment ratio (%) in East Asia (developing only) in 1995 to that in 2000?
Provide a succinct answer. 0.66. What is the ratio of the Gross enrolment ratio (%) of High income in 1995 to that in 2000?
Make the answer very short. 0.95. What is the ratio of the Gross enrolment ratio (%) in Russian Federation in 1995 to that in 2000?
Your answer should be very brief. 0.84. What is the ratio of the Gross enrolment ratio (%) in Slovenia in 1995 to that in 2000?
Offer a very short reply. 0.77. What is the ratio of the Gross enrolment ratio (%) in East Asia (developing only) in 1995 to that in 2001?
Your answer should be compact. 0.64. What is the ratio of the Gross enrolment ratio (%) of High income in 1995 to that in 2001?
Provide a succinct answer. 0.92. What is the ratio of the Gross enrolment ratio (%) in Russian Federation in 1995 to that in 2001?
Keep it short and to the point. 0.77. What is the ratio of the Gross enrolment ratio (%) of Slovenia in 1995 to that in 2001?
Make the answer very short. 0.79. What is the ratio of the Gross enrolment ratio (%) of East Asia (developing only) in 1995 to that in 2002?
Provide a short and direct response. 0.66. What is the ratio of the Gross enrolment ratio (%) in High income in 1995 to that in 2002?
Make the answer very short. 0.91. What is the ratio of the Gross enrolment ratio (%) of Russian Federation in 1995 to that in 2002?
Make the answer very short. 0.75. What is the ratio of the Gross enrolment ratio (%) in Slovenia in 1995 to that in 2002?
Your response must be concise. 0.81. What is the ratio of the Gross enrolment ratio (%) in East Asia (developing only) in 1995 to that in 2003?
Ensure brevity in your answer.  0.63. What is the ratio of the Gross enrolment ratio (%) in High income in 1995 to that in 2003?
Keep it short and to the point. 0.91. What is the ratio of the Gross enrolment ratio (%) in Russian Federation in 1995 to that in 2003?
Provide a succinct answer. 0.75. What is the ratio of the Gross enrolment ratio (%) of Slovenia in 1995 to that in 2003?
Offer a terse response. 0.89. What is the ratio of the Gross enrolment ratio (%) of East Asia (developing only) in 1995 to that in 2004?
Make the answer very short. 0.59. What is the ratio of the Gross enrolment ratio (%) of High income in 1995 to that in 2004?
Provide a short and direct response. 0.9. What is the ratio of the Gross enrolment ratio (%) of Russian Federation in 1995 to that in 2004?
Provide a succinct answer. 0.74. What is the ratio of the Gross enrolment ratio (%) in Slovenia in 1995 to that in 2004?
Keep it short and to the point. 1.03. What is the ratio of the Gross enrolment ratio (%) of East Asia (developing only) in 1999 to that in 2000?
Your answer should be very brief. 0.95. What is the ratio of the Gross enrolment ratio (%) in Russian Federation in 1999 to that in 2000?
Make the answer very short. 0.96. What is the ratio of the Gross enrolment ratio (%) of Slovenia in 1999 to that in 2000?
Offer a very short reply. 0.98. What is the ratio of the Gross enrolment ratio (%) of East Asia (developing only) in 1999 to that in 2001?
Keep it short and to the point. 0.93. What is the ratio of the Gross enrolment ratio (%) of High income in 1999 to that in 2001?
Your answer should be very brief. 0.95. What is the ratio of the Gross enrolment ratio (%) in Russian Federation in 1999 to that in 2001?
Offer a very short reply. 0.88. What is the ratio of the Gross enrolment ratio (%) in East Asia (developing only) in 1999 to that in 2002?
Your response must be concise. 0.95. What is the ratio of the Gross enrolment ratio (%) of High income in 1999 to that in 2002?
Ensure brevity in your answer.  0.94. What is the ratio of the Gross enrolment ratio (%) of Russian Federation in 1999 to that in 2002?
Give a very brief answer. 0.86. What is the ratio of the Gross enrolment ratio (%) in Slovenia in 1999 to that in 2002?
Your answer should be very brief. 1.03. What is the ratio of the Gross enrolment ratio (%) of East Asia (developing only) in 1999 to that in 2003?
Offer a very short reply. 0.9. What is the ratio of the Gross enrolment ratio (%) in High income in 1999 to that in 2003?
Your answer should be very brief. 0.94. What is the ratio of the Gross enrolment ratio (%) of Russian Federation in 1999 to that in 2003?
Provide a short and direct response. 0.85. What is the ratio of the Gross enrolment ratio (%) of Slovenia in 1999 to that in 2003?
Your response must be concise. 1.12. What is the ratio of the Gross enrolment ratio (%) in East Asia (developing only) in 1999 to that in 2004?
Offer a terse response. 0.85. What is the ratio of the Gross enrolment ratio (%) in High income in 1999 to that in 2004?
Provide a succinct answer. 0.94. What is the ratio of the Gross enrolment ratio (%) in Russian Federation in 1999 to that in 2004?
Provide a succinct answer. 0.84. What is the ratio of the Gross enrolment ratio (%) in Slovenia in 1999 to that in 2004?
Make the answer very short. 1.31. What is the ratio of the Gross enrolment ratio (%) in East Asia (developing only) in 2000 to that in 2001?
Your answer should be very brief. 0.98. What is the ratio of the Gross enrolment ratio (%) of High income in 2000 to that in 2001?
Provide a short and direct response. 0.97. What is the ratio of the Gross enrolment ratio (%) in Russian Federation in 2000 to that in 2001?
Make the answer very short. 0.92. What is the ratio of the Gross enrolment ratio (%) of Slovenia in 2000 to that in 2001?
Offer a very short reply. 1.02. What is the ratio of the Gross enrolment ratio (%) of East Asia (developing only) in 2000 to that in 2002?
Offer a very short reply. 1. What is the ratio of the Gross enrolment ratio (%) in High income in 2000 to that in 2002?
Your answer should be very brief. 0.95. What is the ratio of the Gross enrolment ratio (%) in Russian Federation in 2000 to that in 2002?
Provide a short and direct response. 0.9. What is the ratio of the Gross enrolment ratio (%) in Slovenia in 2000 to that in 2002?
Give a very brief answer. 1.05. What is the ratio of the Gross enrolment ratio (%) of East Asia (developing only) in 2000 to that in 2003?
Offer a terse response. 0.95. What is the ratio of the Gross enrolment ratio (%) of High income in 2000 to that in 2003?
Offer a terse response. 0.96. What is the ratio of the Gross enrolment ratio (%) of Russian Federation in 2000 to that in 2003?
Offer a terse response. 0.89. What is the ratio of the Gross enrolment ratio (%) of Slovenia in 2000 to that in 2003?
Make the answer very short. 1.14. What is the ratio of the Gross enrolment ratio (%) in East Asia (developing only) in 2000 to that in 2004?
Your answer should be very brief. 0.9. What is the ratio of the Gross enrolment ratio (%) of High income in 2000 to that in 2004?
Keep it short and to the point. 0.95. What is the ratio of the Gross enrolment ratio (%) of Russian Federation in 2000 to that in 2004?
Give a very brief answer. 0.88. What is the ratio of the Gross enrolment ratio (%) of Slovenia in 2000 to that in 2004?
Offer a very short reply. 1.34. What is the ratio of the Gross enrolment ratio (%) of East Asia (developing only) in 2001 to that in 2002?
Provide a short and direct response. 1.03. What is the ratio of the Gross enrolment ratio (%) in High income in 2001 to that in 2002?
Offer a terse response. 0.99. What is the ratio of the Gross enrolment ratio (%) in Russian Federation in 2001 to that in 2002?
Your answer should be very brief. 0.97. What is the ratio of the Gross enrolment ratio (%) of Slovenia in 2001 to that in 2002?
Offer a terse response. 1.03. What is the ratio of the Gross enrolment ratio (%) in East Asia (developing only) in 2001 to that in 2003?
Offer a terse response. 0.97. What is the ratio of the Gross enrolment ratio (%) in High income in 2001 to that in 2003?
Ensure brevity in your answer.  0.99. What is the ratio of the Gross enrolment ratio (%) in Russian Federation in 2001 to that in 2003?
Give a very brief answer. 0.97. What is the ratio of the Gross enrolment ratio (%) in Slovenia in 2001 to that in 2003?
Make the answer very short. 1.12. What is the ratio of the Gross enrolment ratio (%) in East Asia (developing only) in 2001 to that in 2004?
Make the answer very short. 0.92. What is the ratio of the Gross enrolment ratio (%) in High income in 2001 to that in 2004?
Give a very brief answer. 0.98. What is the ratio of the Gross enrolment ratio (%) of Russian Federation in 2001 to that in 2004?
Offer a terse response. 0.95. What is the ratio of the Gross enrolment ratio (%) in Slovenia in 2001 to that in 2004?
Your answer should be very brief. 1.31. What is the ratio of the Gross enrolment ratio (%) in East Asia (developing only) in 2002 to that in 2003?
Your answer should be very brief. 0.95. What is the ratio of the Gross enrolment ratio (%) of Slovenia in 2002 to that in 2003?
Give a very brief answer. 1.09. What is the ratio of the Gross enrolment ratio (%) of East Asia (developing only) in 2002 to that in 2004?
Your answer should be compact. 0.89. What is the ratio of the Gross enrolment ratio (%) in Russian Federation in 2002 to that in 2004?
Give a very brief answer. 0.98. What is the ratio of the Gross enrolment ratio (%) of Slovenia in 2002 to that in 2004?
Offer a very short reply. 1.27. What is the ratio of the Gross enrolment ratio (%) in East Asia (developing only) in 2003 to that in 2004?
Your response must be concise. 0.94. What is the ratio of the Gross enrolment ratio (%) of High income in 2003 to that in 2004?
Your answer should be very brief. 0.99. What is the ratio of the Gross enrolment ratio (%) of Russian Federation in 2003 to that in 2004?
Your response must be concise. 0.99. What is the ratio of the Gross enrolment ratio (%) of Slovenia in 2003 to that in 2004?
Keep it short and to the point. 1.17. What is the difference between the highest and the second highest Gross enrolment ratio (%) of East Asia (developing only)?
Your answer should be very brief. 2.35. What is the difference between the highest and the second highest Gross enrolment ratio (%) in High income?
Offer a terse response. 0.35. What is the difference between the highest and the second highest Gross enrolment ratio (%) of Russian Federation?
Give a very brief answer. 1.09. What is the difference between the highest and the second highest Gross enrolment ratio (%) in Slovenia?
Your response must be concise. 1.48. What is the difference between the highest and the lowest Gross enrolment ratio (%) in East Asia (developing only)?
Your response must be concise. 17.19. What is the difference between the highest and the lowest Gross enrolment ratio (%) of High income?
Provide a succinct answer. 7.36. What is the difference between the highest and the lowest Gross enrolment ratio (%) of Russian Federation?
Give a very brief answer. 22.15. What is the difference between the highest and the lowest Gross enrolment ratio (%) in Slovenia?
Offer a very short reply. 19.09. 